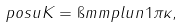<formula> <loc_0><loc_0><loc_500><loc_500>\ p o s u K = \i m m p l u n 1 \pi \kappa ,</formula> 